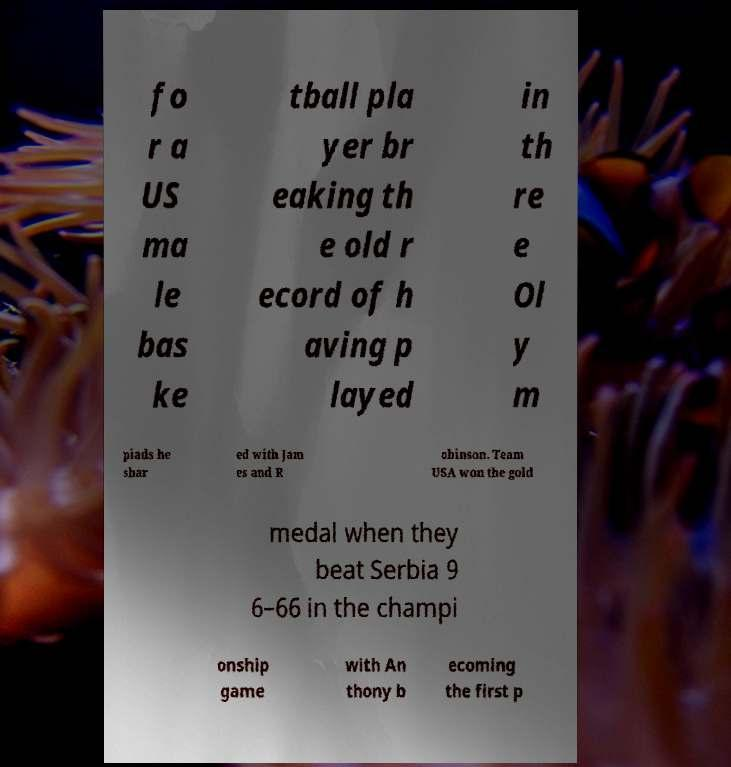For documentation purposes, I need the text within this image transcribed. Could you provide that? fo r a US ma le bas ke tball pla yer br eaking th e old r ecord of h aving p layed in th re e Ol y m piads he shar ed with Jam es and R obinson. Team USA won the gold medal when they beat Serbia 9 6–66 in the champi onship game with An thony b ecoming the first p 